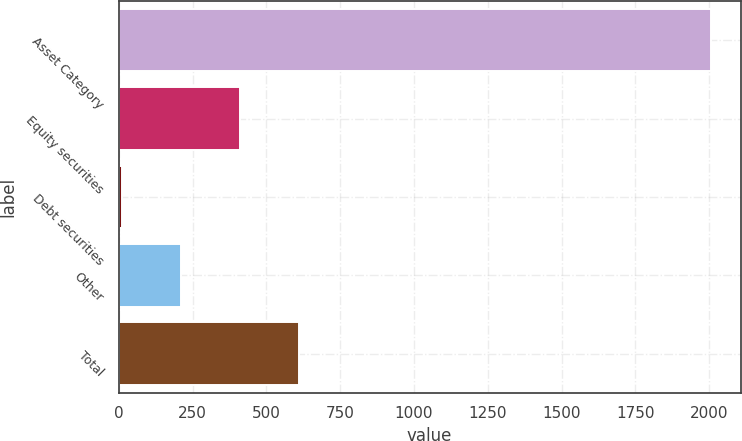Convert chart to OTSL. <chart><loc_0><loc_0><loc_500><loc_500><bar_chart><fcel>Asset Category<fcel>Equity securities<fcel>Debt securities<fcel>Other<fcel>Total<nl><fcel>2006<fcel>410.4<fcel>11.5<fcel>210.95<fcel>609.85<nl></chart> 